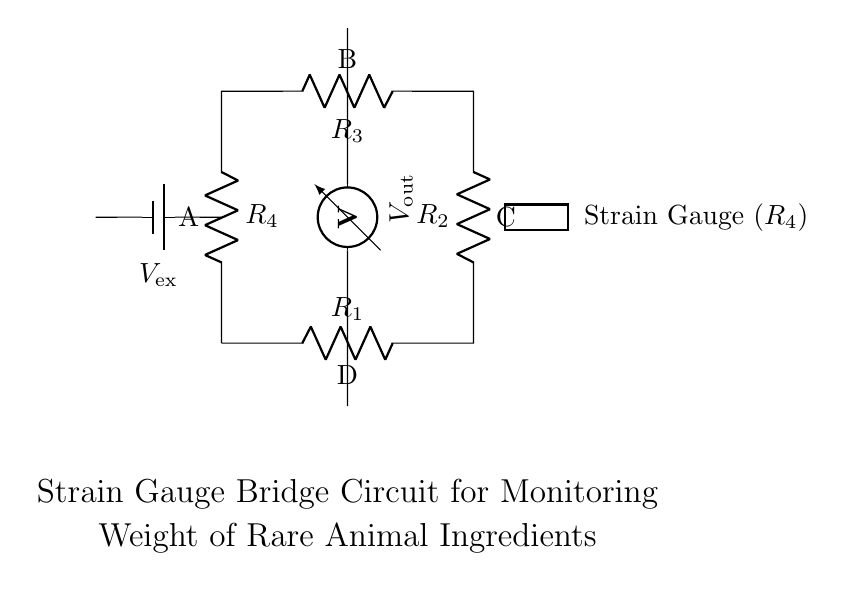What type of circuit is represented here? This circuit is a bridge circuit, specifically a strain gauge bridge circuit, used for measuring small changes in resistance. It consists of four resistors arranged in a diamond shape.
Answer: Bridge circuit What is the role of the strain gauge in this circuit? The strain gauge acts as one of the resistors in the bridge and changes its resistance based on the weight of the rare animal ingredients applied to it; this change causes a voltage imbalance that can be measured.
Answer: To measure weight What is indicated by the voltmeter in this circuit? The voltmeter measures the voltage difference across two points in the circuit, which indicates the level of imbalance in the bridge caused by changes in resistance due to weight.
Answer: Voltage difference How many resistors are present in this bridge circuit? There are four resistors labeled R1, R2, R3, and R4 in the bridge configuration.
Answer: Four resistors What happens when the weight of the rare animal ingredients changes? When the weight changes, it alters the resistance of the strain gauge (R4), leading to a change in the voltage output measured by the voltmeter, which reflects the weight change.
Answer: Voltage changes What is the output voltage referred to in this circuit? The output voltage is labeled as Vout, which corresponds to the voltage measured across points B and D, resulting from the resistance changes in the bridge circuit.
Answer: Vout 